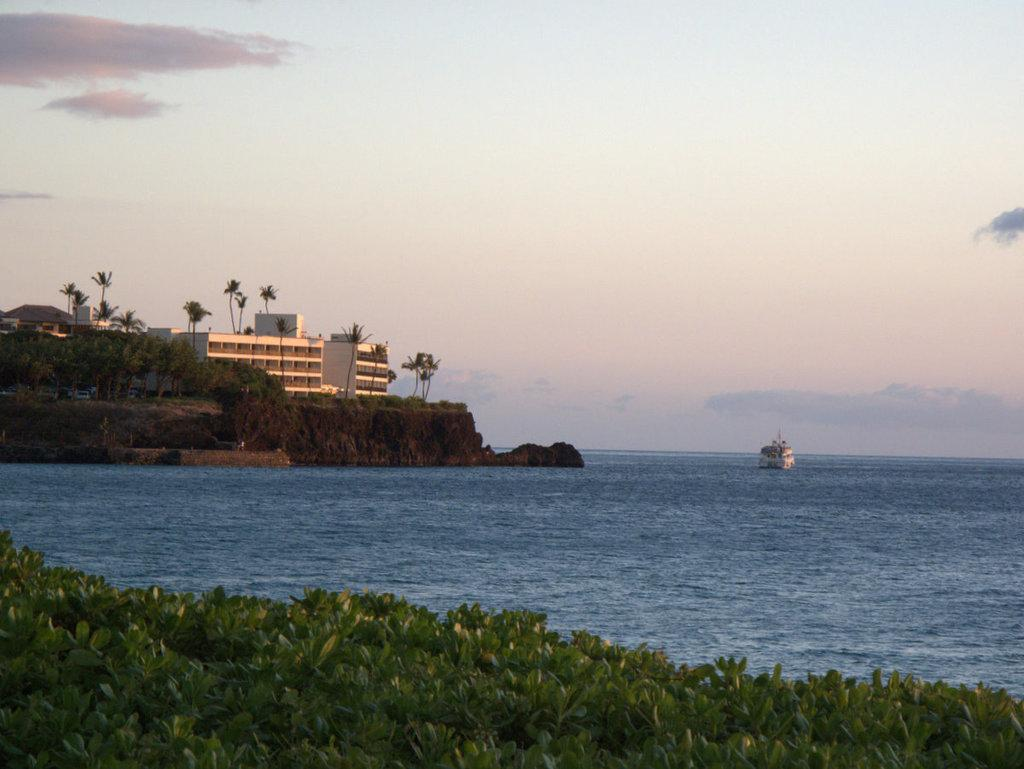What type of terrain is visible in the image? There is grass in the image. What natural element is also present in the image? There is water in the image. What man-made object can be seen in the image? There is a ship in the image. What can be seen in the background of the image? There are trees, buildings, and clouds in the sky in the background of the image. What is the name of the person who is wearing a sweater in the image? There is no person wearing a sweater in the image; it features a ship on water with grass and trees in the background. 